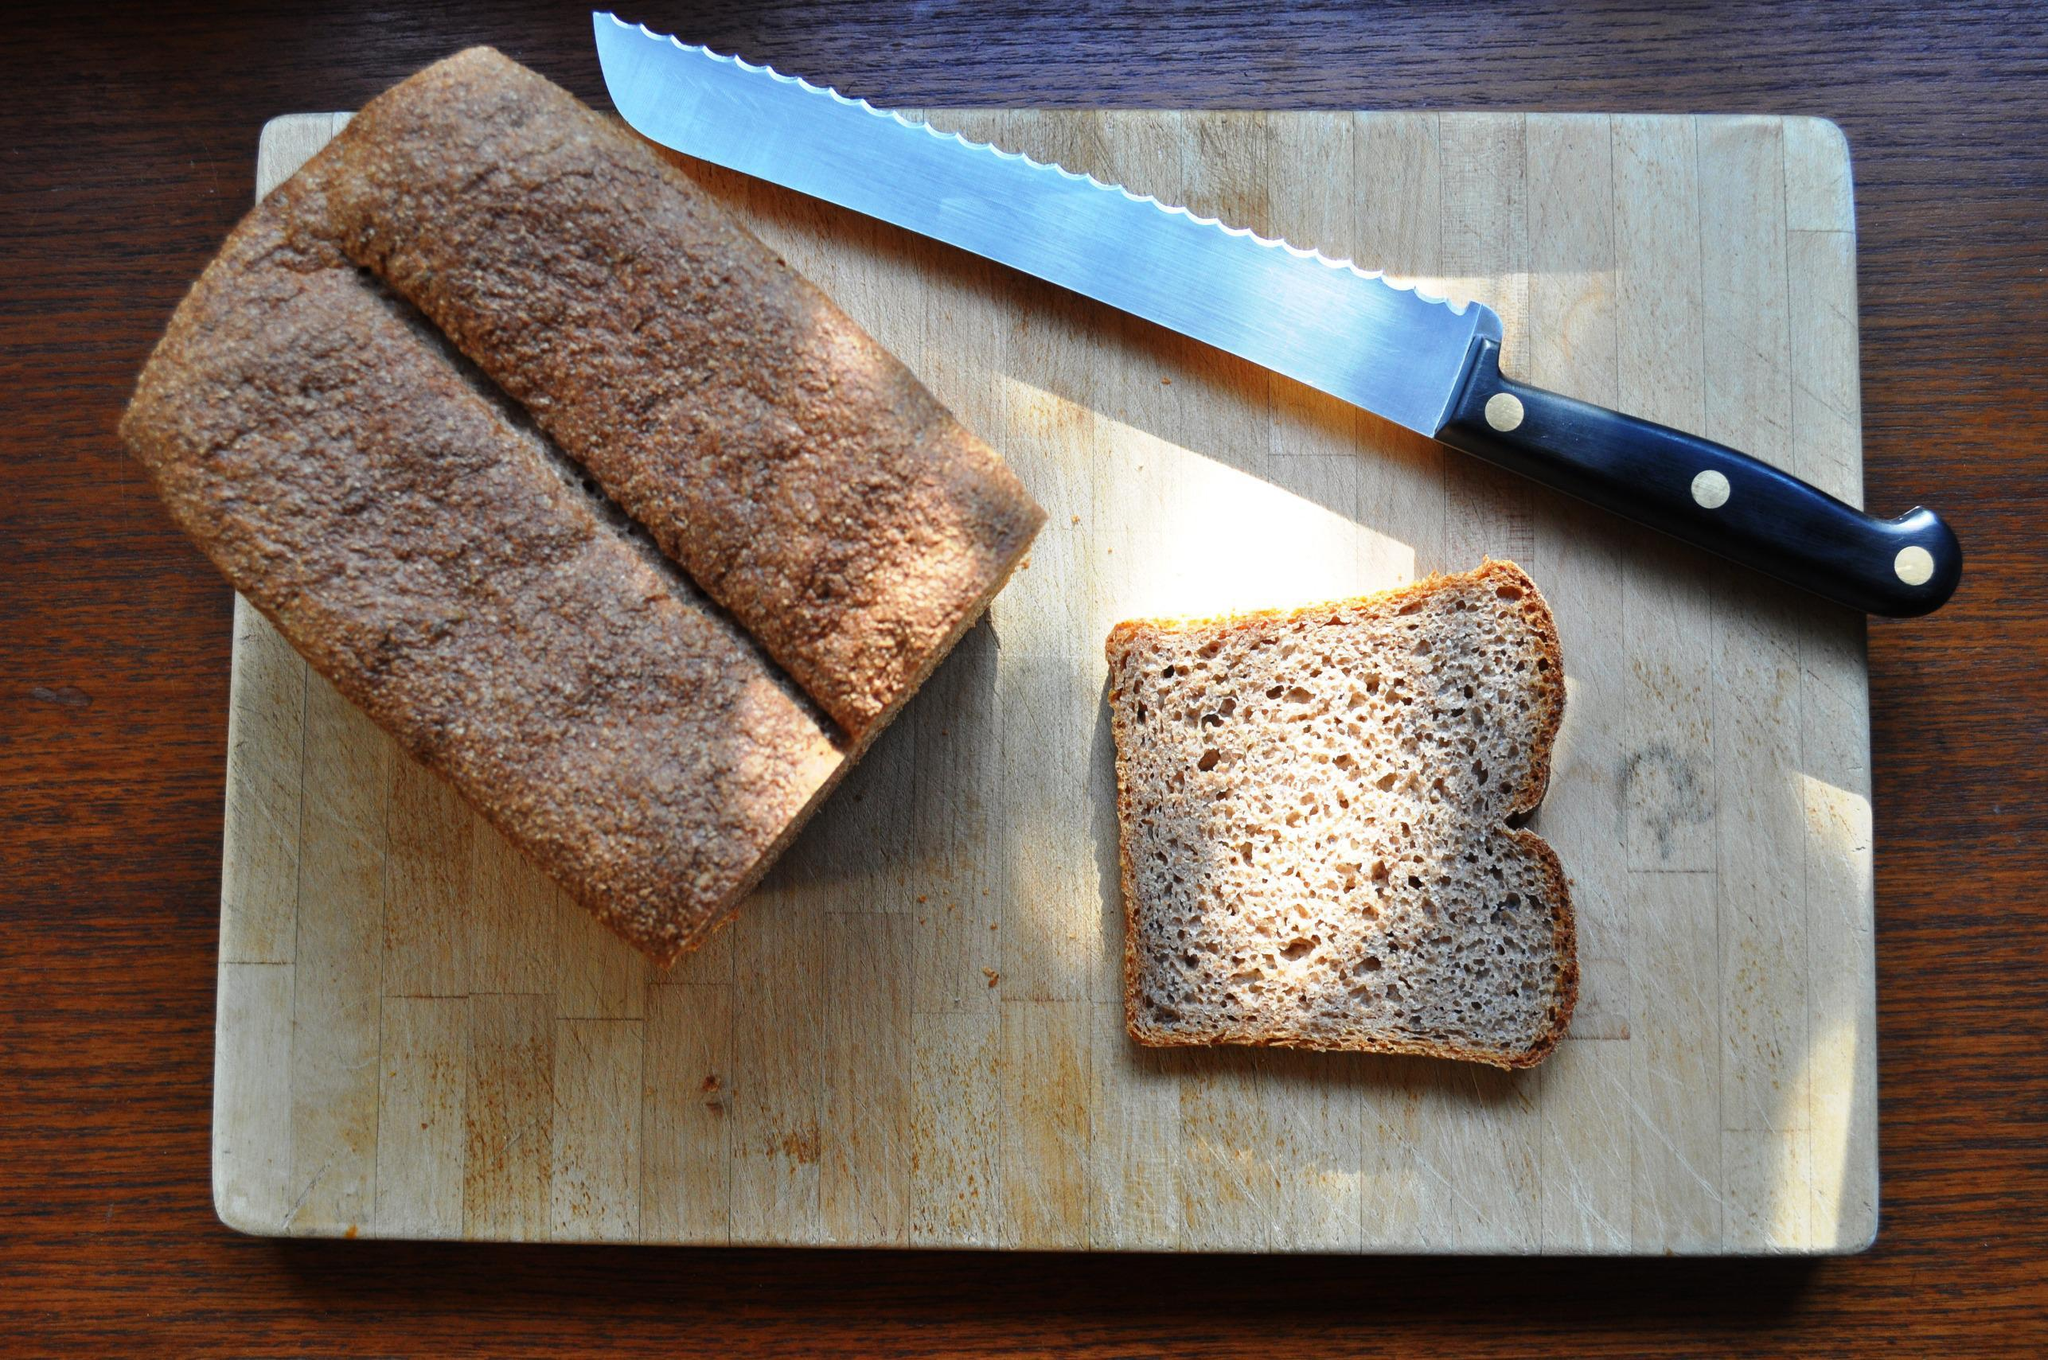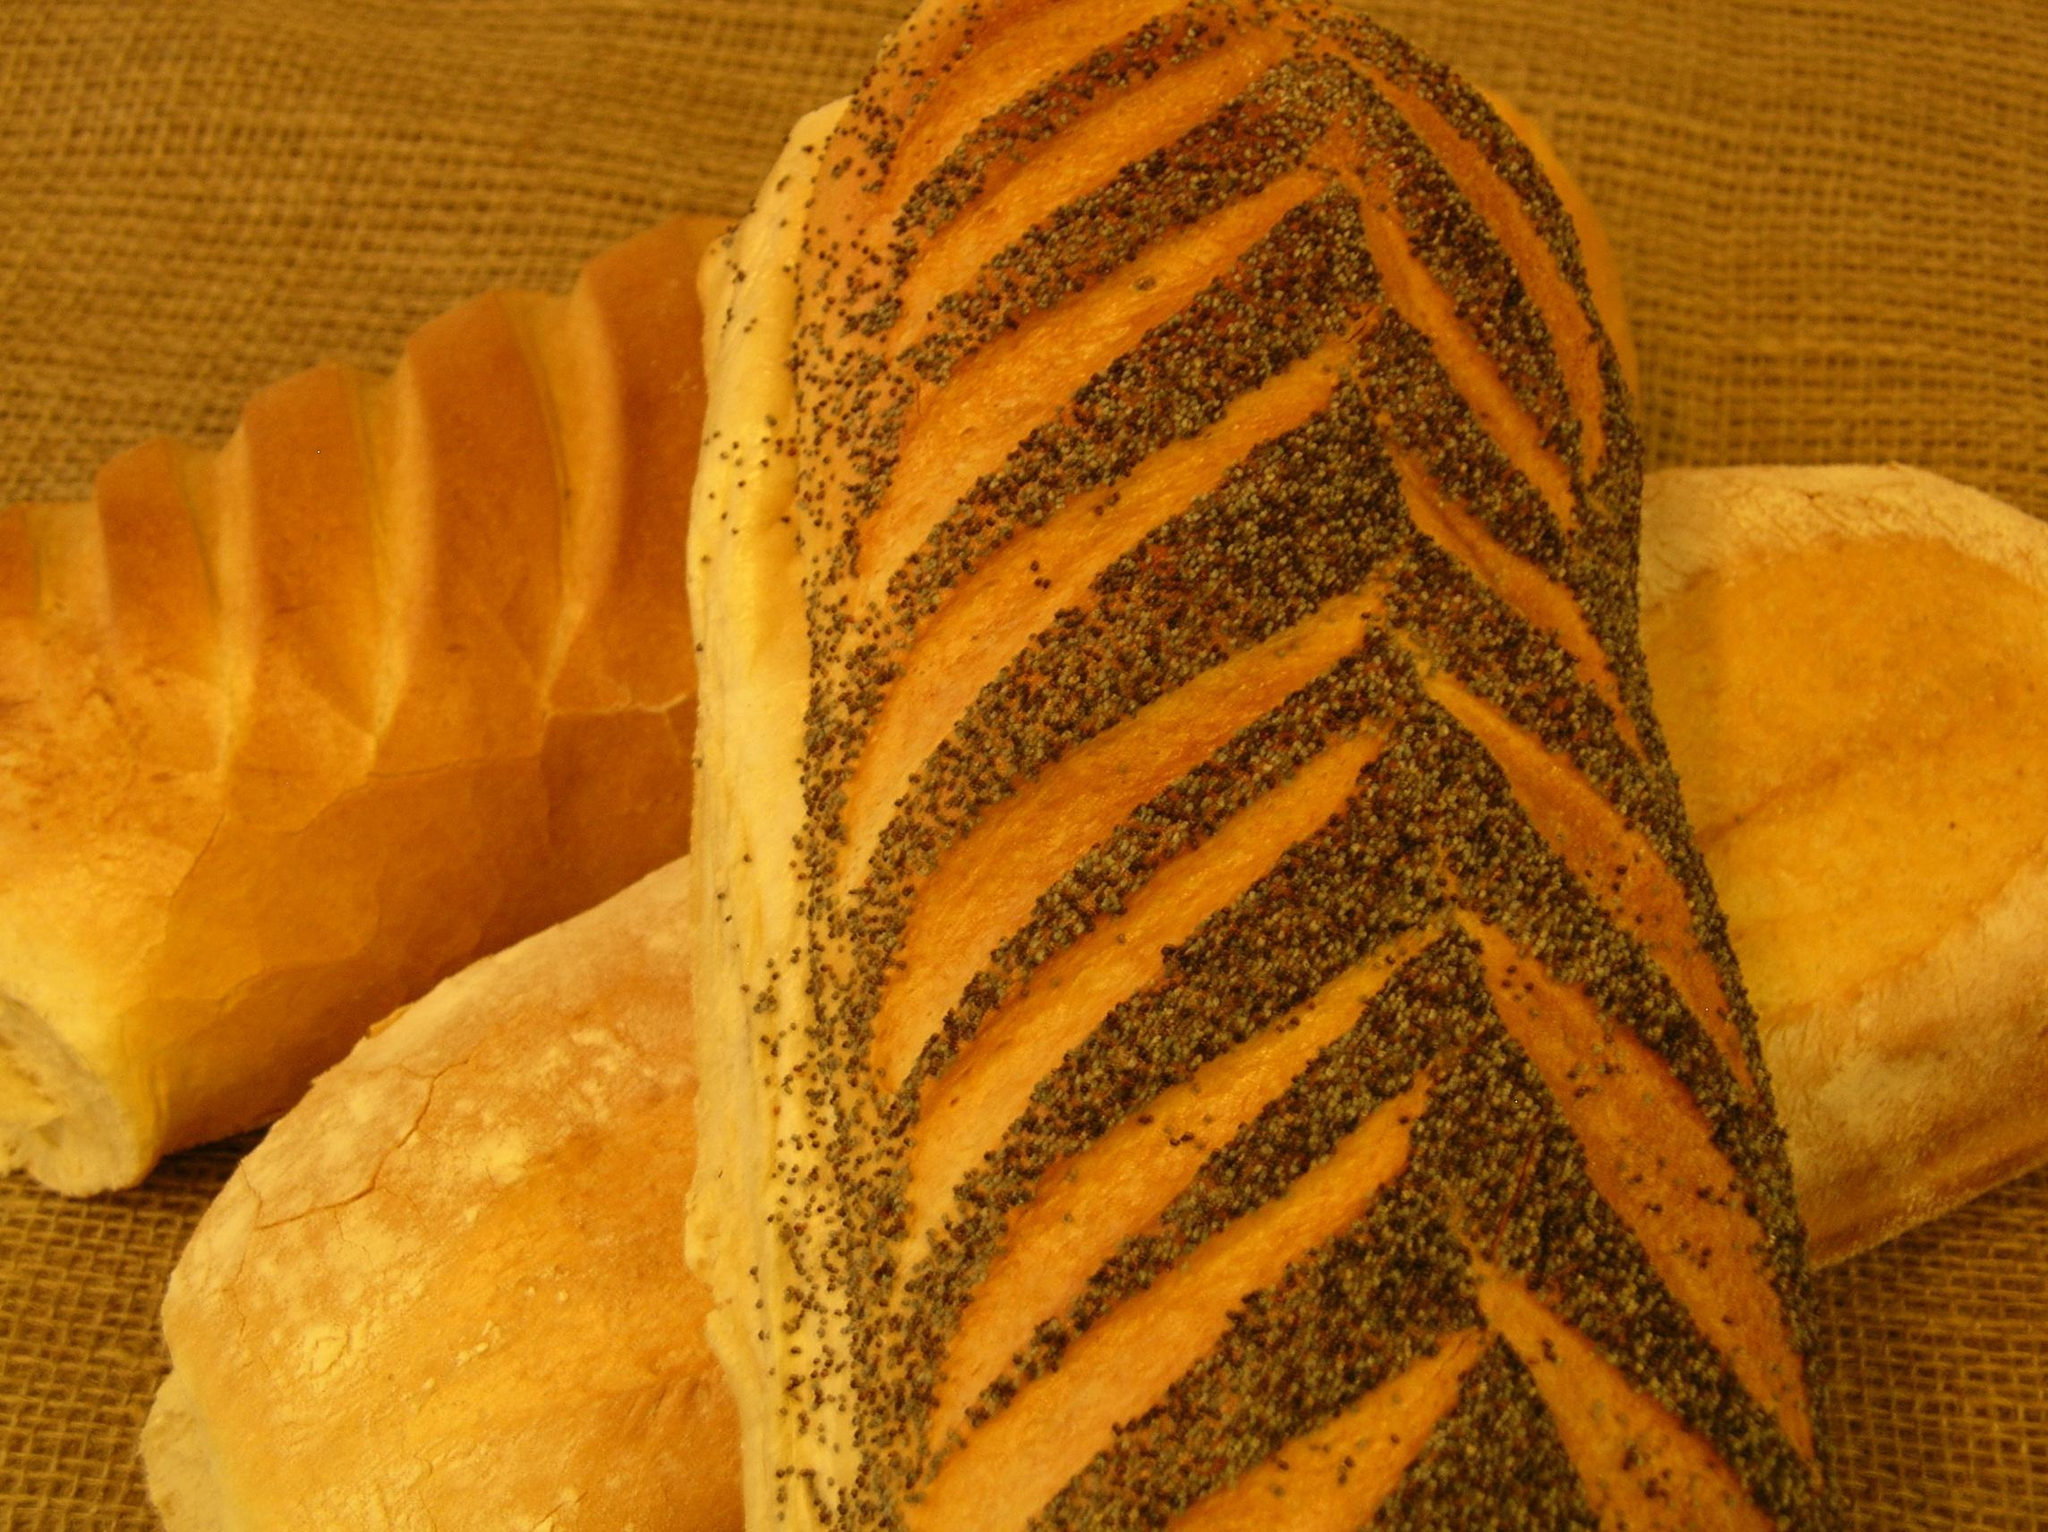The first image is the image on the left, the second image is the image on the right. For the images displayed, is the sentence "In one image, two or more loaves of bread feature diagonal designs that were cut into the top of the dough prior to baking." factually correct? Answer yes or no. Yes. The first image is the image on the left, the second image is the image on the right. Assess this claim about the two images: "One image shows a bread loaf with at least one cut slice on a cutting board, and the other image includes multiple whole loaves with diagonal slash marks on top.". Correct or not? Answer yes or no. Yes. 